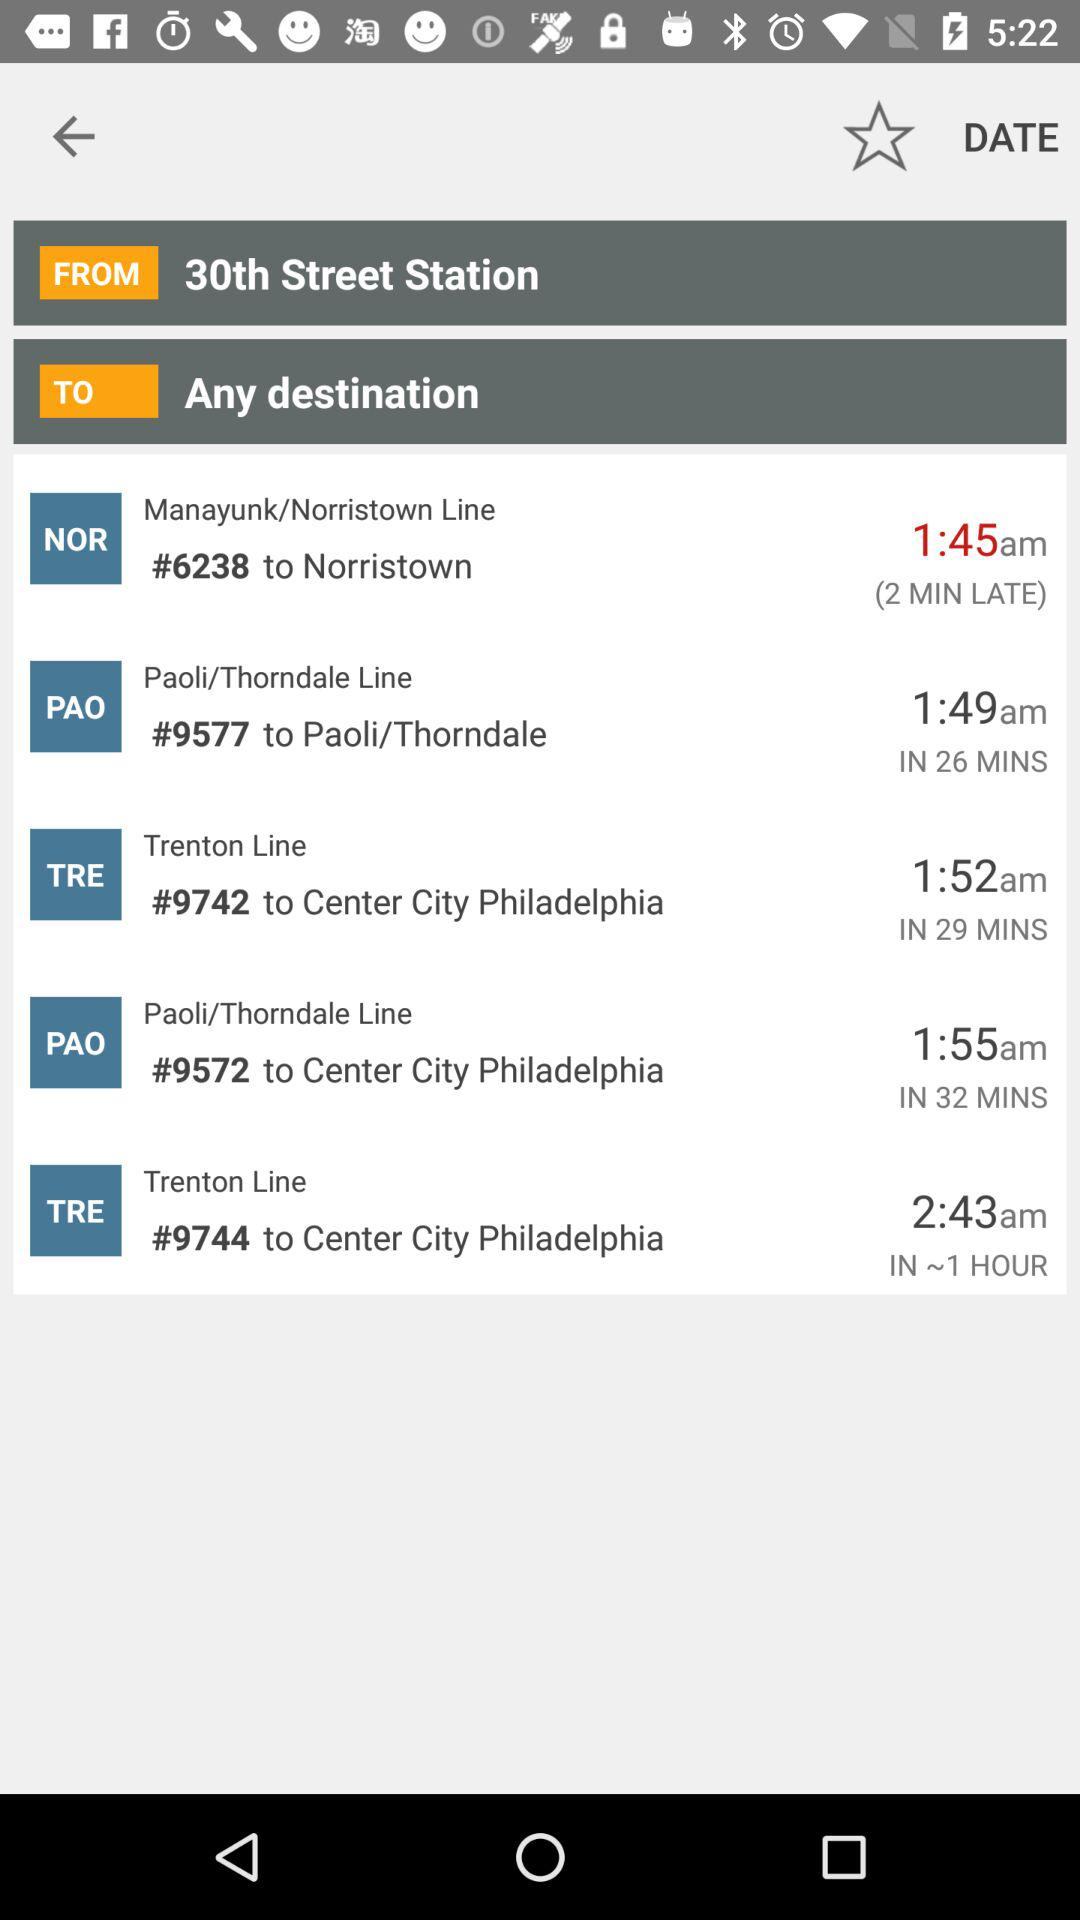How many minutes is the train late on the Norristown Line? On the Norristown Line, the train is 2 minutes late. 